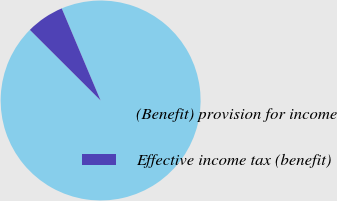<chart> <loc_0><loc_0><loc_500><loc_500><pie_chart><fcel>(Benefit) provision for income<fcel>Effective income tax (benefit)<nl><fcel>93.84%<fcel>6.16%<nl></chart> 